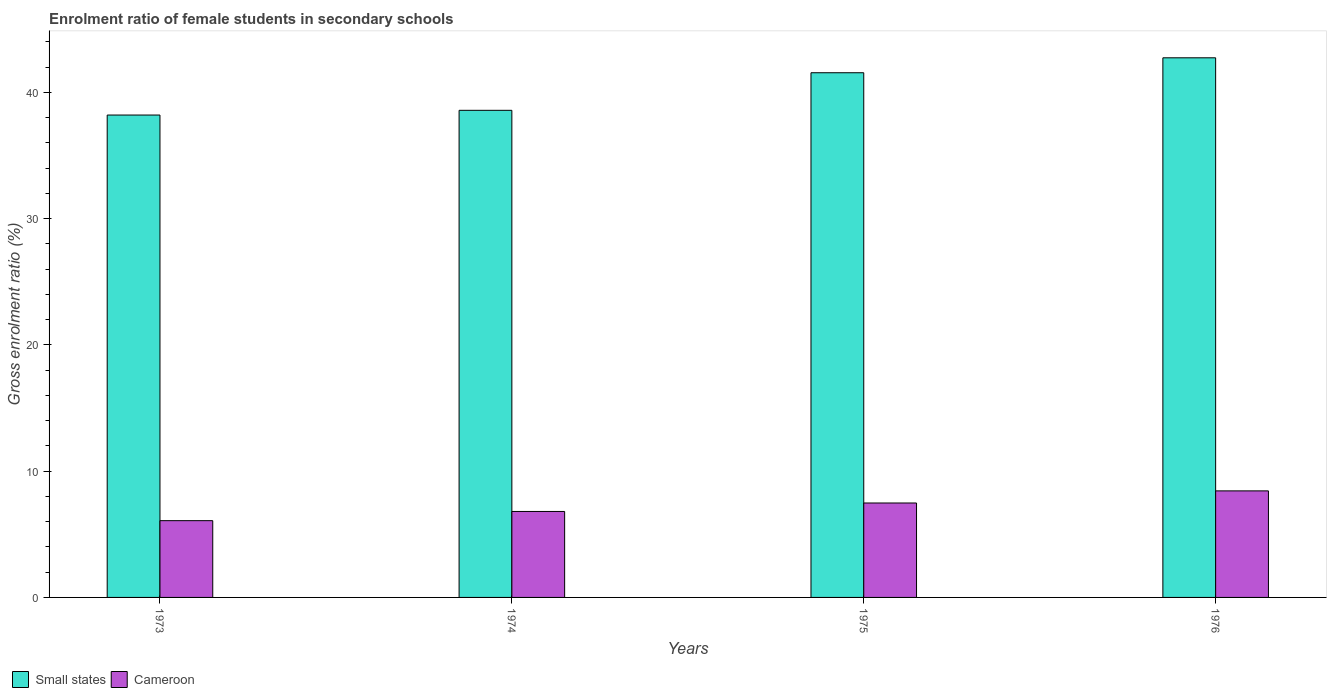How many bars are there on the 2nd tick from the left?
Ensure brevity in your answer.  2. How many bars are there on the 2nd tick from the right?
Ensure brevity in your answer.  2. What is the label of the 4th group of bars from the left?
Make the answer very short. 1976. In how many cases, is the number of bars for a given year not equal to the number of legend labels?
Your answer should be very brief. 0. What is the enrolment ratio of female students in secondary schools in Cameroon in 1975?
Give a very brief answer. 7.48. Across all years, what is the maximum enrolment ratio of female students in secondary schools in Small states?
Offer a terse response. 42.73. Across all years, what is the minimum enrolment ratio of female students in secondary schools in Small states?
Ensure brevity in your answer.  38.2. In which year was the enrolment ratio of female students in secondary schools in Small states maximum?
Offer a terse response. 1976. What is the total enrolment ratio of female students in secondary schools in Small states in the graph?
Your response must be concise. 161.04. What is the difference between the enrolment ratio of female students in secondary schools in Small states in 1974 and that in 1976?
Ensure brevity in your answer.  -4.16. What is the difference between the enrolment ratio of female students in secondary schools in Small states in 1975 and the enrolment ratio of female students in secondary schools in Cameroon in 1974?
Your answer should be very brief. 34.74. What is the average enrolment ratio of female students in secondary schools in Small states per year?
Keep it short and to the point. 40.26. In the year 1975, what is the difference between the enrolment ratio of female students in secondary schools in Small states and enrolment ratio of female students in secondary schools in Cameroon?
Offer a very short reply. 34.07. What is the ratio of the enrolment ratio of female students in secondary schools in Cameroon in 1973 to that in 1976?
Provide a succinct answer. 0.72. Is the enrolment ratio of female students in secondary schools in Cameroon in 1973 less than that in 1974?
Your answer should be compact. Yes. Is the difference between the enrolment ratio of female students in secondary schools in Small states in 1973 and 1975 greater than the difference between the enrolment ratio of female students in secondary schools in Cameroon in 1973 and 1975?
Offer a very short reply. No. What is the difference between the highest and the second highest enrolment ratio of female students in secondary schools in Small states?
Ensure brevity in your answer.  1.18. What is the difference between the highest and the lowest enrolment ratio of female students in secondary schools in Cameroon?
Your answer should be compact. 2.36. In how many years, is the enrolment ratio of female students in secondary schools in Cameroon greater than the average enrolment ratio of female students in secondary schools in Cameroon taken over all years?
Keep it short and to the point. 2. Is the sum of the enrolment ratio of female students in secondary schools in Small states in 1974 and 1975 greater than the maximum enrolment ratio of female students in secondary schools in Cameroon across all years?
Make the answer very short. Yes. What does the 1st bar from the left in 1976 represents?
Keep it short and to the point. Small states. What does the 1st bar from the right in 1976 represents?
Your answer should be very brief. Cameroon. Are the values on the major ticks of Y-axis written in scientific E-notation?
Your answer should be very brief. No. Where does the legend appear in the graph?
Keep it short and to the point. Bottom left. How many legend labels are there?
Ensure brevity in your answer.  2. What is the title of the graph?
Your response must be concise. Enrolment ratio of female students in secondary schools. Does "Kosovo" appear as one of the legend labels in the graph?
Your response must be concise. No. What is the label or title of the X-axis?
Your response must be concise. Years. What is the label or title of the Y-axis?
Offer a very short reply. Gross enrolment ratio (%). What is the Gross enrolment ratio (%) in Small states in 1973?
Give a very brief answer. 38.2. What is the Gross enrolment ratio (%) in Cameroon in 1973?
Your answer should be very brief. 6.08. What is the Gross enrolment ratio (%) of Small states in 1974?
Keep it short and to the point. 38.57. What is the Gross enrolment ratio (%) in Cameroon in 1974?
Ensure brevity in your answer.  6.81. What is the Gross enrolment ratio (%) of Small states in 1975?
Keep it short and to the point. 41.55. What is the Gross enrolment ratio (%) in Cameroon in 1975?
Keep it short and to the point. 7.48. What is the Gross enrolment ratio (%) of Small states in 1976?
Your response must be concise. 42.73. What is the Gross enrolment ratio (%) in Cameroon in 1976?
Give a very brief answer. 8.44. Across all years, what is the maximum Gross enrolment ratio (%) in Small states?
Keep it short and to the point. 42.73. Across all years, what is the maximum Gross enrolment ratio (%) in Cameroon?
Give a very brief answer. 8.44. Across all years, what is the minimum Gross enrolment ratio (%) in Small states?
Your answer should be compact. 38.2. Across all years, what is the minimum Gross enrolment ratio (%) in Cameroon?
Provide a short and direct response. 6.08. What is the total Gross enrolment ratio (%) of Small states in the graph?
Provide a short and direct response. 161.04. What is the total Gross enrolment ratio (%) in Cameroon in the graph?
Your response must be concise. 28.8. What is the difference between the Gross enrolment ratio (%) in Small states in 1973 and that in 1974?
Provide a succinct answer. -0.37. What is the difference between the Gross enrolment ratio (%) in Cameroon in 1973 and that in 1974?
Your response must be concise. -0.73. What is the difference between the Gross enrolment ratio (%) of Small states in 1973 and that in 1975?
Give a very brief answer. -3.35. What is the difference between the Gross enrolment ratio (%) in Cameroon in 1973 and that in 1975?
Provide a short and direct response. -1.4. What is the difference between the Gross enrolment ratio (%) in Small states in 1973 and that in 1976?
Your response must be concise. -4.53. What is the difference between the Gross enrolment ratio (%) in Cameroon in 1973 and that in 1976?
Provide a succinct answer. -2.36. What is the difference between the Gross enrolment ratio (%) in Small states in 1974 and that in 1975?
Make the answer very short. -2.98. What is the difference between the Gross enrolment ratio (%) in Cameroon in 1974 and that in 1975?
Make the answer very short. -0.67. What is the difference between the Gross enrolment ratio (%) of Small states in 1974 and that in 1976?
Give a very brief answer. -4.16. What is the difference between the Gross enrolment ratio (%) in Cameroon in 1974 and that in 1976?
Make the answer very short. -1.63. What is the difference between the Gross enrolment ratio (%) in Small states in 1975 and that in 1976?
Offer a very short reply. -1.18. What is the difference between the Gross enrolment ratio (%) in Cameroon in 1975 and that in 1976?
Your answer should be compact. -0.96. What is the difference between the Gross enrolment ratio (%) of Small states in 1973 and the Gross enrolment ratio (%) of Cameroon in 1974?
Ensure brevity in your answer.  31.39. What is the difference between the Gross enrolment ratio (%) of Small states in 1973 and the Gross enrolment ratio (%) of Cameroon in 1975?
Offer a very short reply. 30.72. What is the difference between the Gross enrolment ratio (%) of Small states in 1973 and the Gross enrolment ratio (%) of Cameroon in 1976?
Provide a succinct answer. 29.76. What is the difference between the Gross enrolment ratio (%) in Small states in 1974 and the Gross enrolment ratio (%) in Cameroon in 1975?
Your answer should be compact. 31.09. What is the difference between the Gross enrolment ratio (%) in Small states in 1974 and the Gross enrolment ratio (%) in Cameroon in 1976?
Provide a succinct answer. 30.13. What is the difference between the Gross enrolment ratio (%) of Small states in 1975 and the Gross enrolment ratio (%) of Cameroon in 1976?
Your answer should be very brief. 33.11. What is the average Gross enrolment ratio (%) in Small states per year?
Make the answer very short. 40.26. What is the average Gross enrolment ratio (%) of Cameroon per year?
Keep it short and to the point. 7.2. In the year 1973, what is the difference between the Gross enrolment ratio (%) of Small states and Gross enrolment ratio (%) of Cameroon?
Provide a short and direct response. 32.12. In the year 1974, what is the difference between the Gross enrolment ratio (%) of Small states and Gross enrolment ratio (%) of Cameroon?
Your response must be concise. 31.76. In the year 1975, what is the difference between the Gross enrolment ratio (%) of Small states and Gross enrolment ratio (%) of Cameroon?
Provide a succinct answer. 34.07. In the year 1976, what is the difference between the Gross enrolment ratio (%) in Small states and Gross enrolment ratio (%) in Cameroon?
Make the answer very short. 34.29. What is the ratio of the Gross enrolment ratio (%) of Small states in 1973 to that in 1974?
Offer a terse response. 0.99. What is the ratio of the Gross enrolment ratio (%) in Cameroon in 1973 to that in 1974?
Provide a short and direct response. 0.89. What is the ratio of the Gross enrolment ratio (%) of Small states in 1973 to that in 1975?
Provide a short and direct response. 0.92. What is the ratio of the Gross enrolment ratio (%) of Cameroon in 1973 to that in 1975?
Provide a short and direct response. 0.81. What is the ratio of the Gross enrolment ratio (%) of Small states in 1973 to that in 1976?
Ensure brevity in your answer.  0.89. What is the ratio of the Gross enrolment ratio (%) of Cameroon in 1973 to that in 1976?
Your answer should be compact. 0.72. What is the ratio of the Gross enrolment ratio (%) in Small states in 1974 to that in 1975?
Your answer should be compact. 0.93. What is the ratio of the Gross enrolment ratio (%) of Cameroon in 1974 to that in 1975?
Offer a terse response. 0.91. What is the ratio of the Gross enrolment ratio (%) of Small states in 1974 to that in 1976?
Offer a terse response. 0.9. What is the ratio of the Gross enrolment ratio (%) in Cameroon in 1974 to that in 1976?
Offer a very short reply. 0.81. What is the ratio of the Gross enrolment ratio (%) in Small states in 1975 to that in 1976?
Your answer should be compact. 0.97. What is the ratio of the Gross enrolment ratio (%) in Cameroon in 1975 to that in 1976?
Ensure brevity in your answer.  0.89. What is the difference between the highest and the second highest Gross enrolment ratio (%) in Small states?
Keep it short and to the point. 1.18. What is the difference between the highest and the second highest Gross enrolment ratio (%) in Cameroon?
Give a very brief answer. 0.96. What is the difference between the highest and the lowest Gross enrolment ratio (%) of Small states?
Your response must be concise. 4.53. What is the difference between the highest and the lowest Gross enrolment ratio (%) of Cameroon?
Provide a succinct answer. 2.36. 